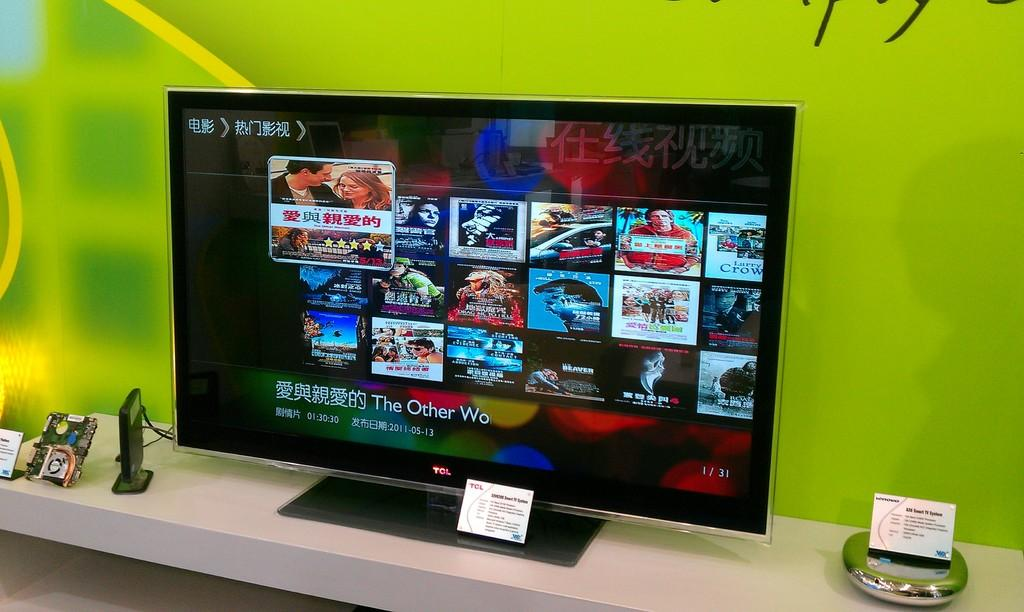<image>
Describe the image concisely. A selection of Asian movies are on the monitor and the one titled "The Other Wo" is selected. 